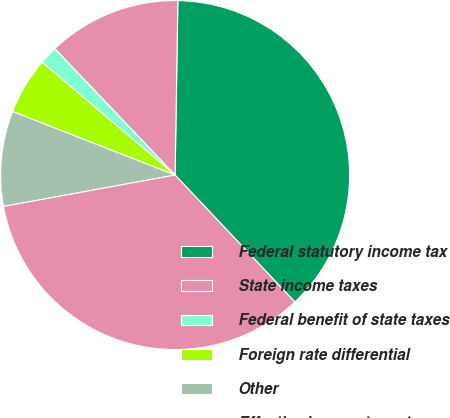Convert chart to OTSL. <chart><loc_0><loc_0><loc_500><loc_500><pie_chart><fcel>Federal statutory income tax<fcel>State income taxes<fcel>Federal benefit of state taxes<fcel>Foreign rate differential<fcel>Other<fcel>Effective income tax rate<nl><fcel>37.71%<fcel>12.36%<fcel>1.7%<fcel>5.26%<fcel>8.81%<fcel>34.16%<nl></chart> 